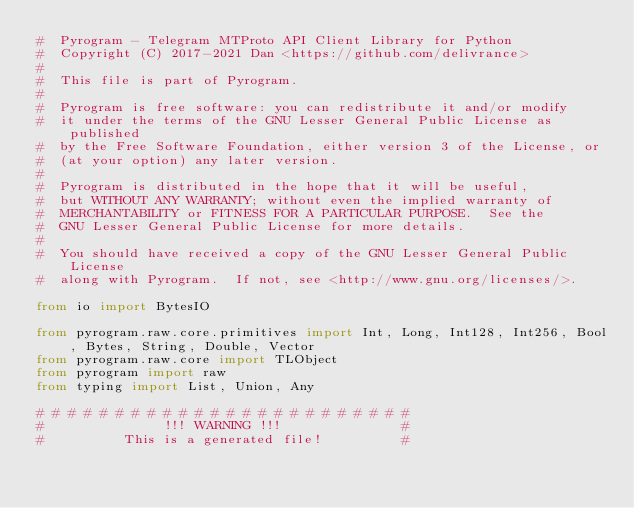<code> <loc_0><loc_0><loc_500><loc_500><_Python_>#  Pyrogram - Telegram MTProto API Client Library for Python
#  Copyright (C) 2017-2021 Dan <https://github.com/delivrance>
#
#  This file is part of Pyrogram.
#
#  Pyrogram is free software: you can redistribute it and/or modify
#  it under the terms of the GNU Lesser General Public License as published
#  by the Free Software Foundation, either version 3 of the License, or
#  (at your option) any later version.
#
#  Pyrogram is distributed in the hope that it will be useful,
#  but WITHOUT ANY WARRANTY; without even the implied warranty of
#  MERCHANTABILITY or FITNESS FOR A PARTICULAR PURPOSE.  See the
#  GNU Lesser General Public License for more details.
#
#  You should have received a copy of the GNU Lesser General Public License
#  along with Pyrogram.  If not, see <http://www.gnu.org/licenses/>.

from io import BytesIO

from pyrogram.raw.core.primitives import Int, Long, Int128, Int256, Bool, Bytes, String, Double, Vector
from pyrogram.raw.core import TLObject
from pyrogram import raw
from typing import List, Union, Any

# # # # # # # # # # # # # # # # # # # # # # # #
#               !!! WARNING !!!               #
#          This is a generated file!          #</code> 